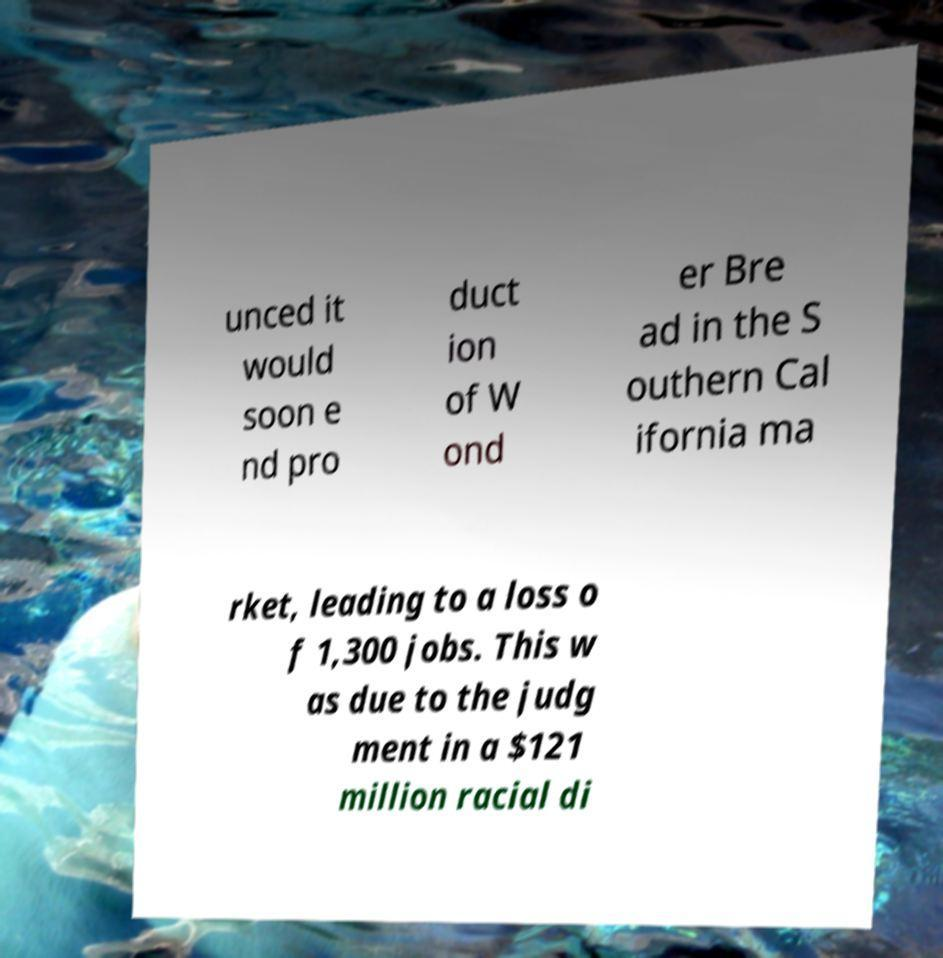Could you assist in decoding the text presented in this image and type it out clearly? unced it would soon e nd pro duct ion of W ond er Bre ad in the S outhern Cal ifornia ma rket, leading to a loss o f 1,300 jobs. This w as due to the judg ment in a $121 million racial di 